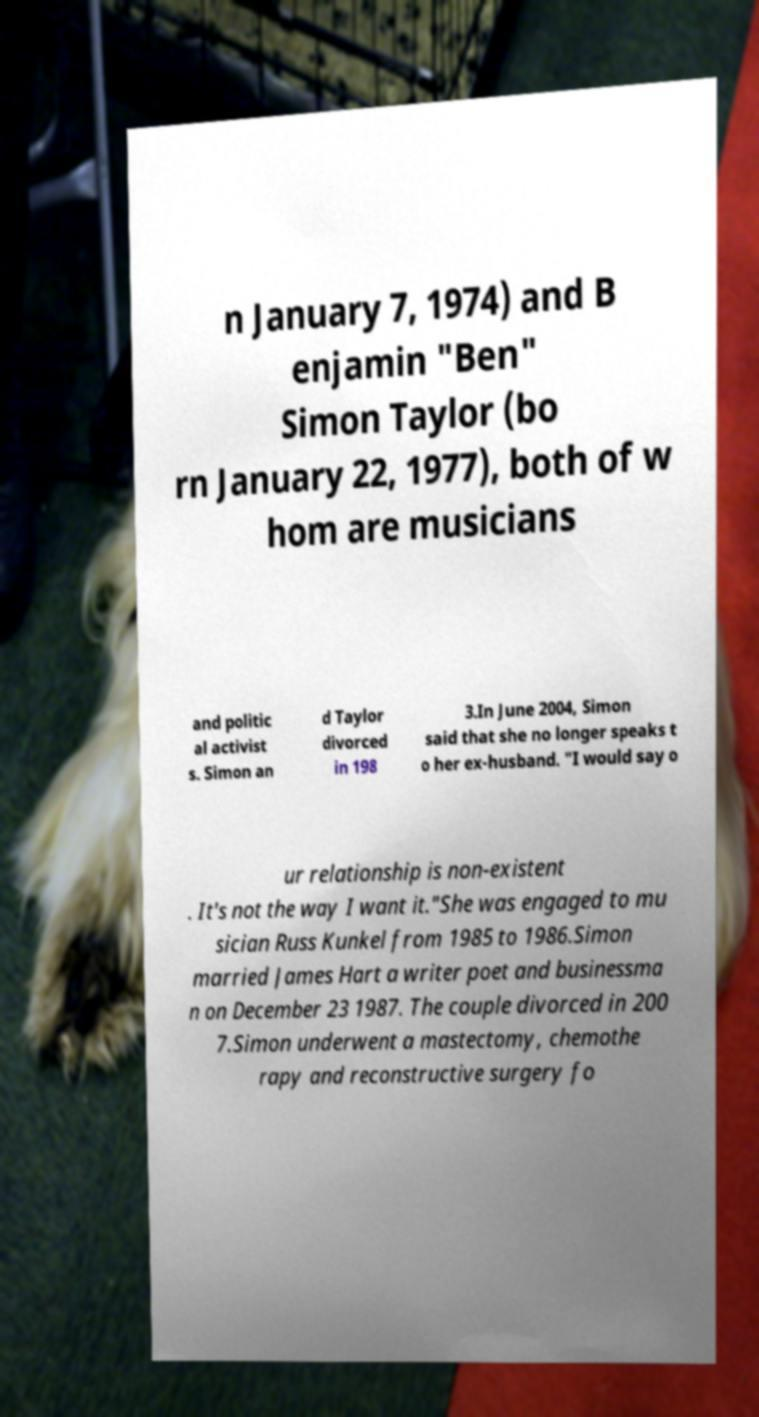Could you assist in decoding the text presented in this image and type it out clearly? n January 7, 1974) and B enjamin "Ben" Simon Taylor (bo rn January 22, 1977), both of w hom are musicians and politic al activist s. Simon an d Taylor divorced in 198 3.In June 2004, Simon said that she no longer speaks t o her ex-husband. "I would say o ur relationship is non-existent . It's not the way I want it."She was engaged to mu sician Russ Kunkel from 1985 to 1986.Simon married James Hart a writer poet and businessma n on December 23 1987. The couple divorced in 200 7.Simon underwent a mastectomy, chemothe rapy and reconstructive surgery fo 